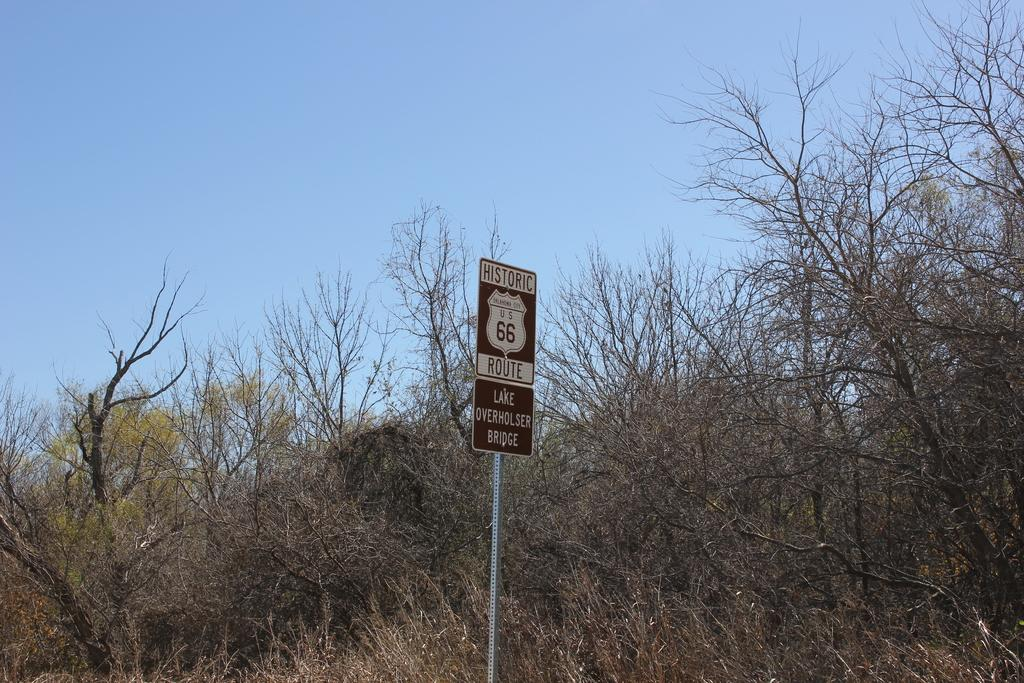What is the main object in the image? There is a sign board with a pole in the image. What can be seen in the background of the image? There are trees and the sky visible in the background of the image. What type of steam is coming out of the sign board in the image? There is no steam present in the image; it is a sign board with a pole and trees and the sky in the background. 